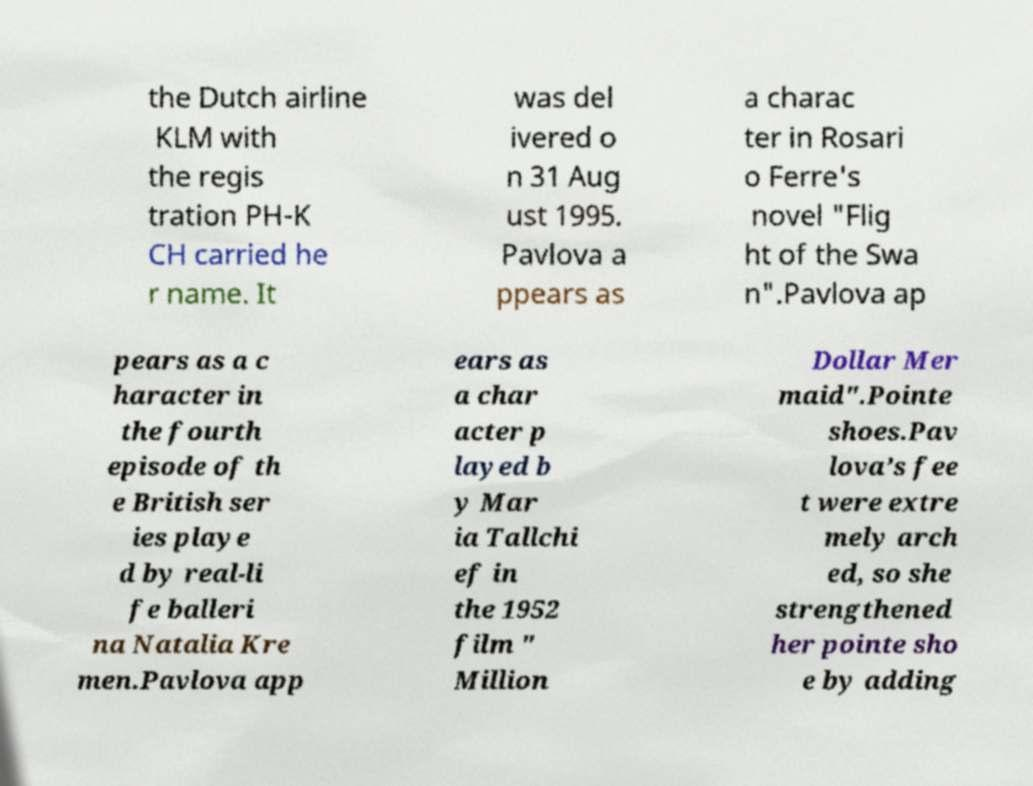Could you extract and type out the text from this image? the Dutch airline KLM with the regis tration PH-K CH carried he r name. It was del ivered o n 31 Aug ust 1995. Pavlova a ppears as a charac ter in Rosari o Ferre's novel "Flig ht of the Swa n".Pavlova ap pears as a c haracter in the fourth episode of th e British ser ies playe d by real-li fe balleri na Natalia Kre men.Pavlova app ears as a char acter p layed b y Mar ia Tallchi ef in the 1952 film " Million Dollar Mer maid".Pointe shoes.Pav lova’s fee t were extre mely arch ed, so she strengthened her pointe sho e by adding 